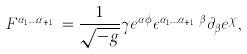<formula> <loc_0><loc_0><loc_500><loc_500>F ^ { \alpha _ { 1 } \dots \alpha _ { q + 1 } } = \frac { 1 } { \sqrt { - g } } \gamma e ^ { \alpha \phi } \epsilon ^ { \alpha _ { 1 } \dots \alpha _ { q + 1 } \beta } \partial _ { \beta } e ^ { \chi } ,</formula> 